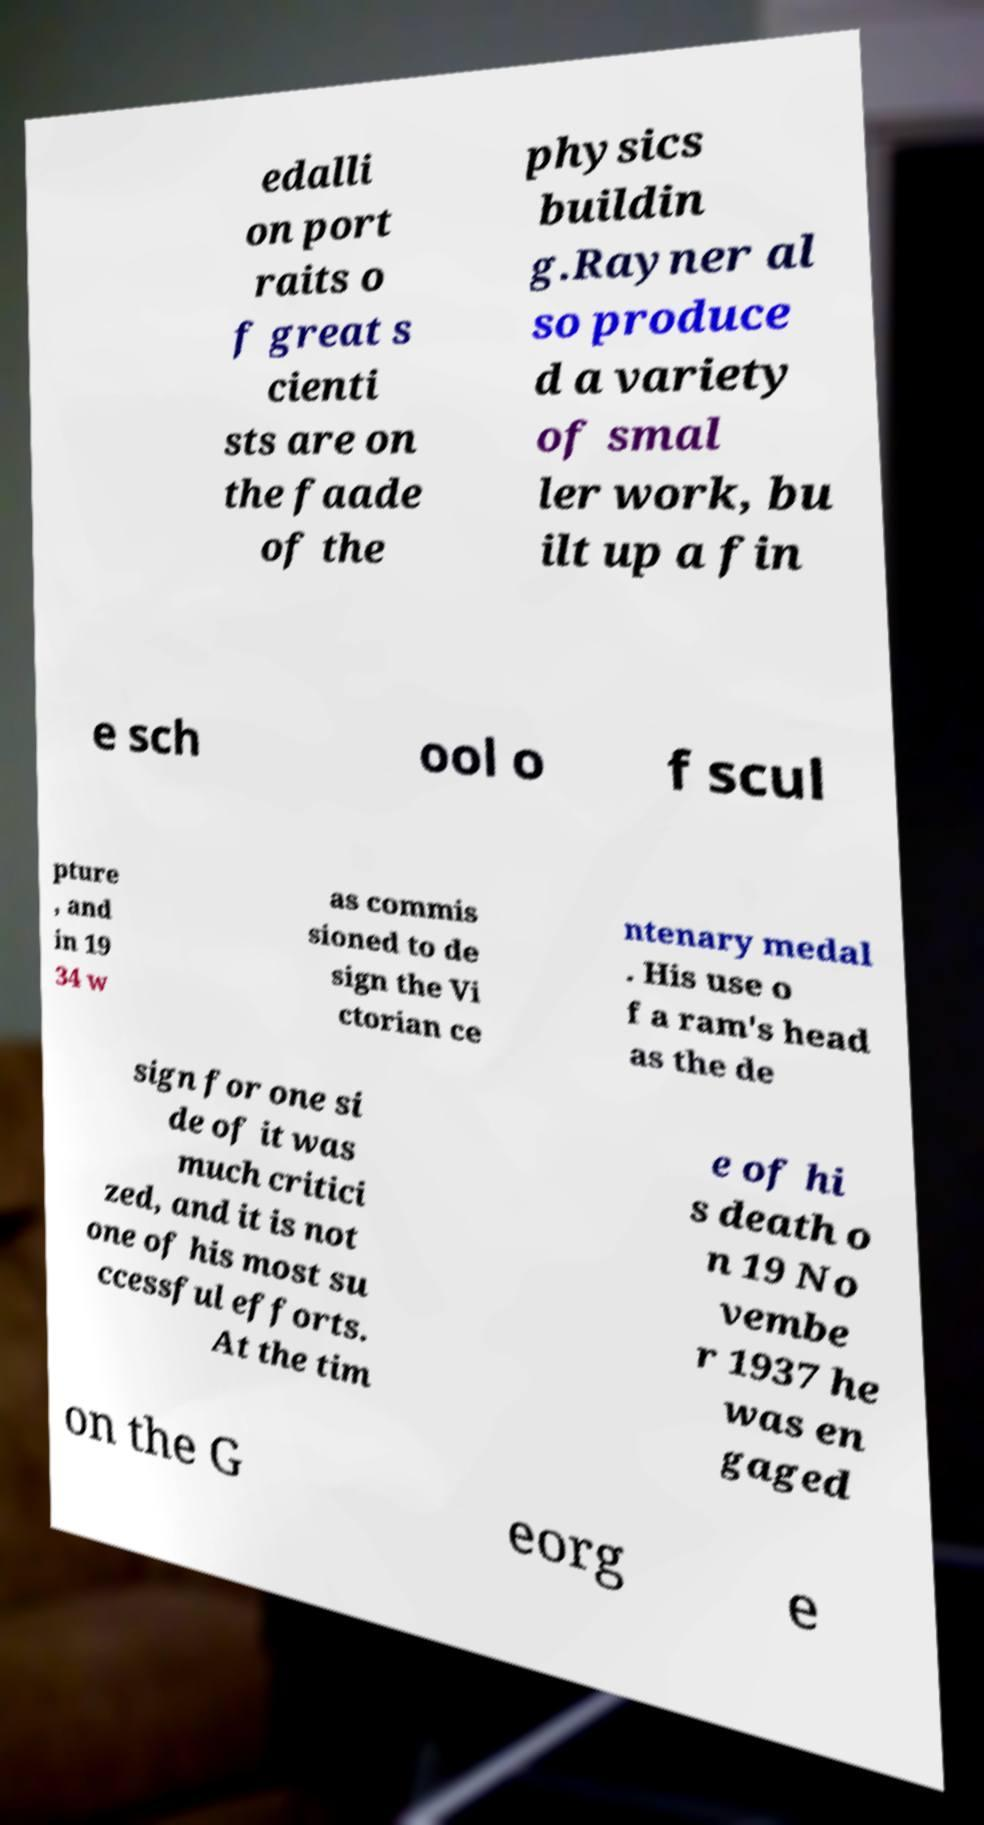Could you extract and type out the text from this image? edalli on port raits o f great s cienti sts are on the faade of the physics buildin g.Rayner al so produce d a variety of smal ler work, bu ilt up a fin e sch ool o f scul pture , and in 19 34 w as commis sioned to de sign the Vi ctorian ce ntenary medal . His use o f a ram's head as the de sign for one si de of it was much critici zed, and it is not one of his most su ccessful efforts. At the tim e of hi s death o n 19 No vembe r 1937 he was en gaged on the G eorg e 